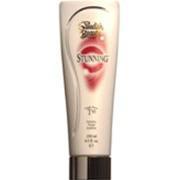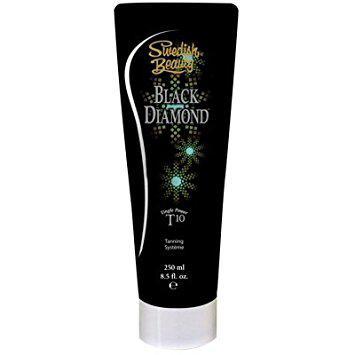The first image is the image on the left, the second image is the image on the right. Analyze the images presented: Is the assertion "One image shows a bottle standing alone, with its lid at the top, and the other image shows a bottle in front of and overlapping its upright box." valid? Answer yes or no. No. The first image is the image on the left, the second image is the image on the right. For the images shown, is this caption "At least one of the images shows the product next to the packaging." true? Answer yes or no. No. 